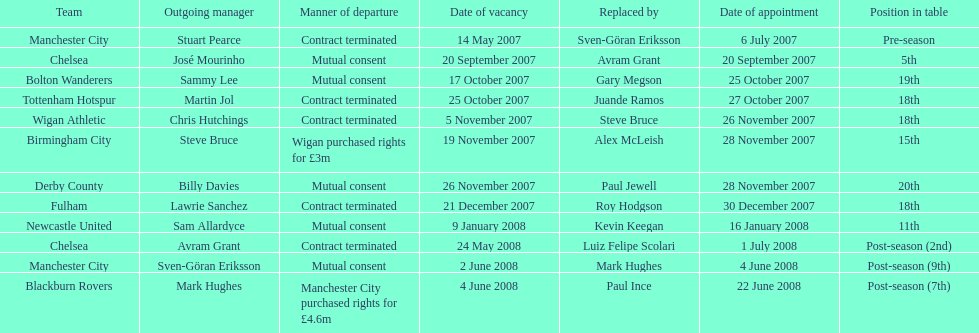For at least how many years was avram grant involved with chelsea? 1. 